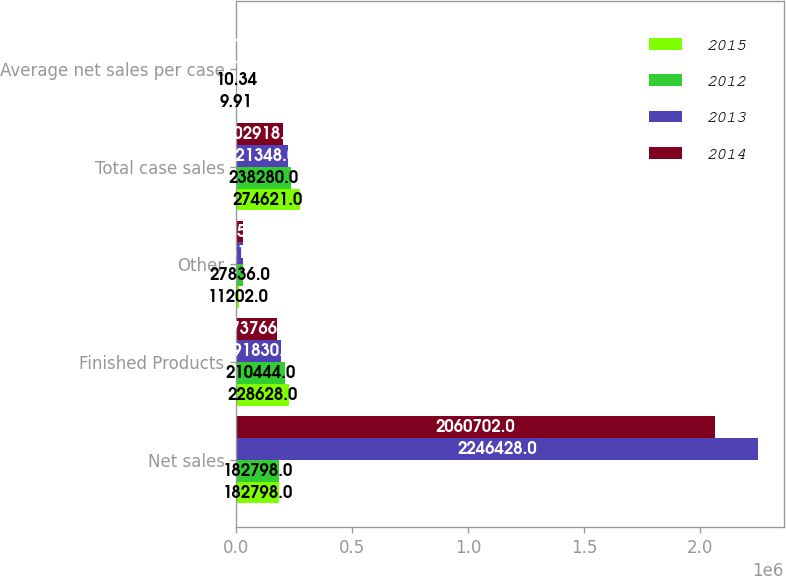Convert chart to OTSL. <chart><loc_0><loc_0><loc_500><loc_500><stacked_bar_chart><ecel><fcel>Net sales<fcel>Finished Products<fcel>Other<fcel>Total case sales<fcel>Average net sales per case<nl><fcel>2015<fcel>182798<fcel>228628<fcel>11202<fcel>274621<fcel>9.91<nl><fcel>2012<fcel>182798<fcel>210444<fcel>27836<fcel>238280<fcel>10.34<nl><fcel>2013<fcel>2.24643e+06<fcel>191830<fcel>29518<fcel>221348<fcel>10.15<nl><fcel>2014<fcel>2.0607e+06<fcel>173766<fcel>29152<fcel>202918<fcel>10.16<nl></chart> 